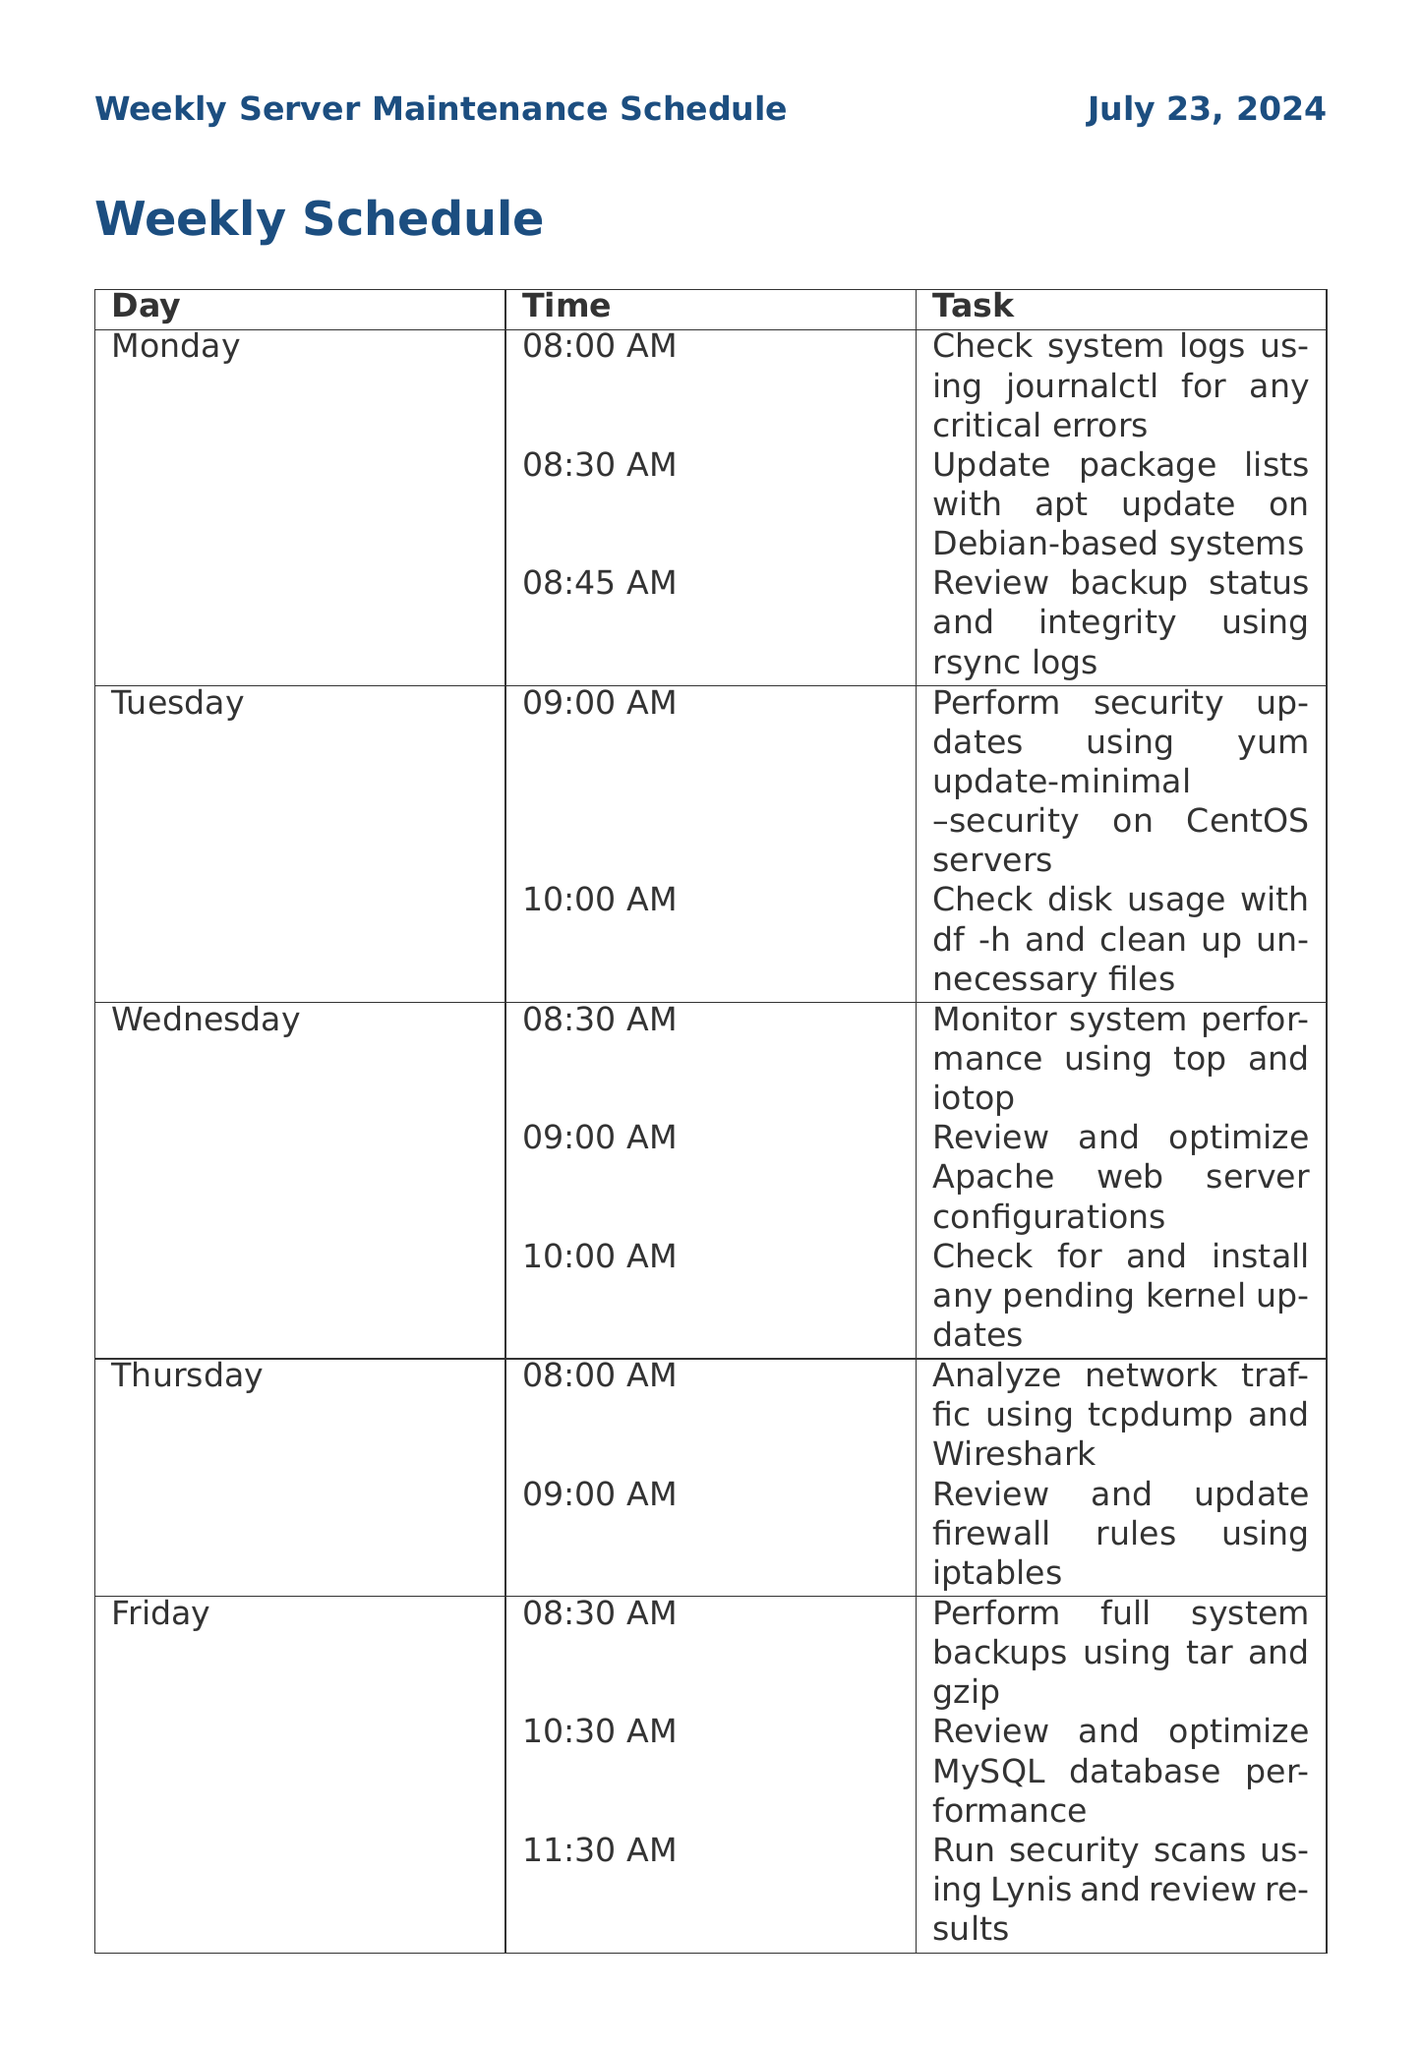What is the first task scheduled on Monday? The first task on Monday is to check system logs using journalctl for any critical errors at 08:00 AM.
Answer: Check system logs using journalctl for any critical errors How long does the task of updating package lists take? The task of updating package lists takes 15 minutes as stated in the schedule.
Answer: 15 minutes Which day has a task that involves monitoring disk usage? The task of checking disk usage is scheduled for Tuesday, which includes cleaning up unnecessary files.
Answer: Tuesday What frequency is assigned to verifying NTP synchronization? The document states that verifying NTP synchronization is a weekly task.
Answer: Weekly What duration is allocated for performing full system backups on Friday? The duration allocated for performing full system backups is stated to be 2 hours in the schedule.
Answer: 2 hours How many tasks are scheduled for Wednesday? Wednesday has three scheduled tasks according to the document.
Answer: Three 